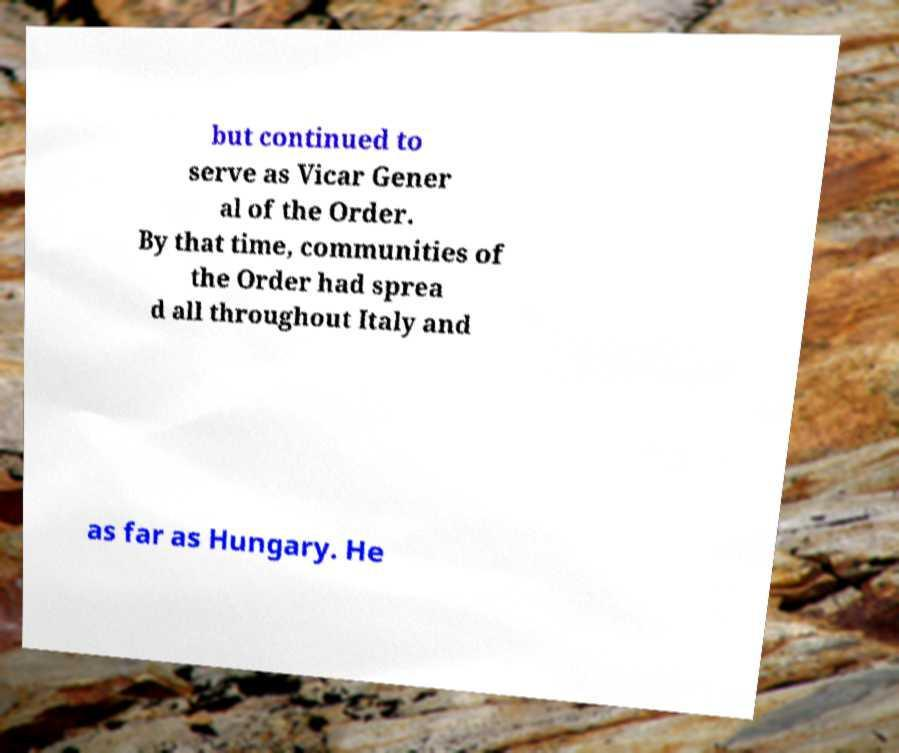Can you accurately transcribe the text from the provided image for me? but continued to serve as Vicar Gener al of the Order. By that time, communities of the Order had sprea d all throughout Italy and as far as Hungary. He 